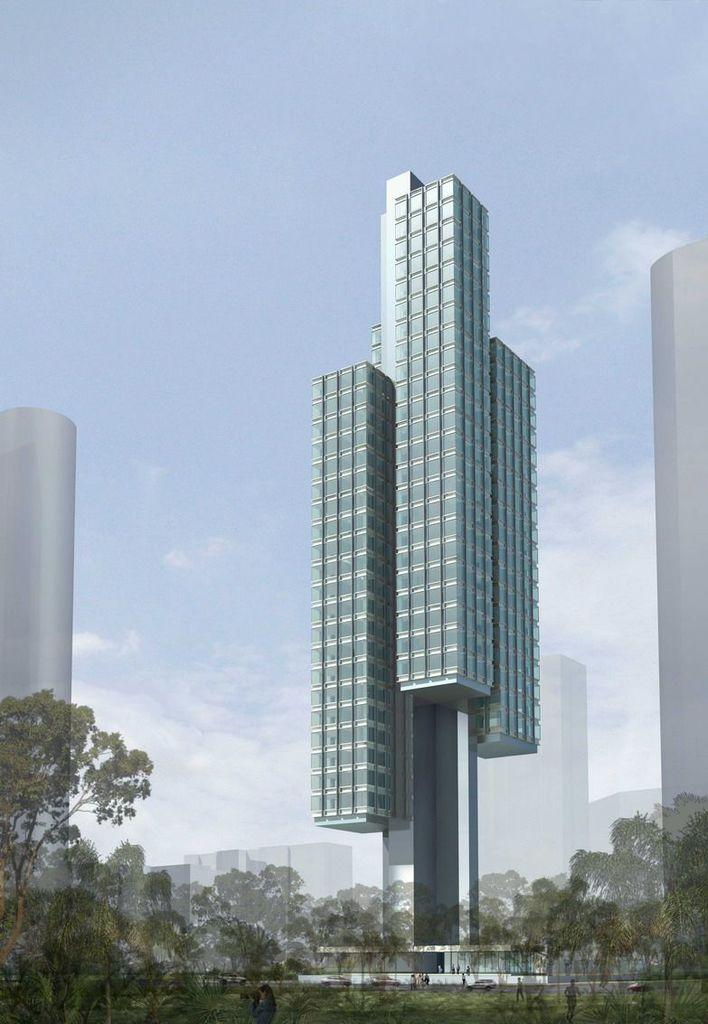What type of structure is present in the image? There is a building in the image. What can be seen in the reflections in the image? There are reflections of trees and buildings in the image. What is visible at the top of the image? The sky is visible at the top of the image. How many cattle are grazing in the image? There are no cattle present in the image. What type of plough is being used in the image? There is no plough present in the image. 